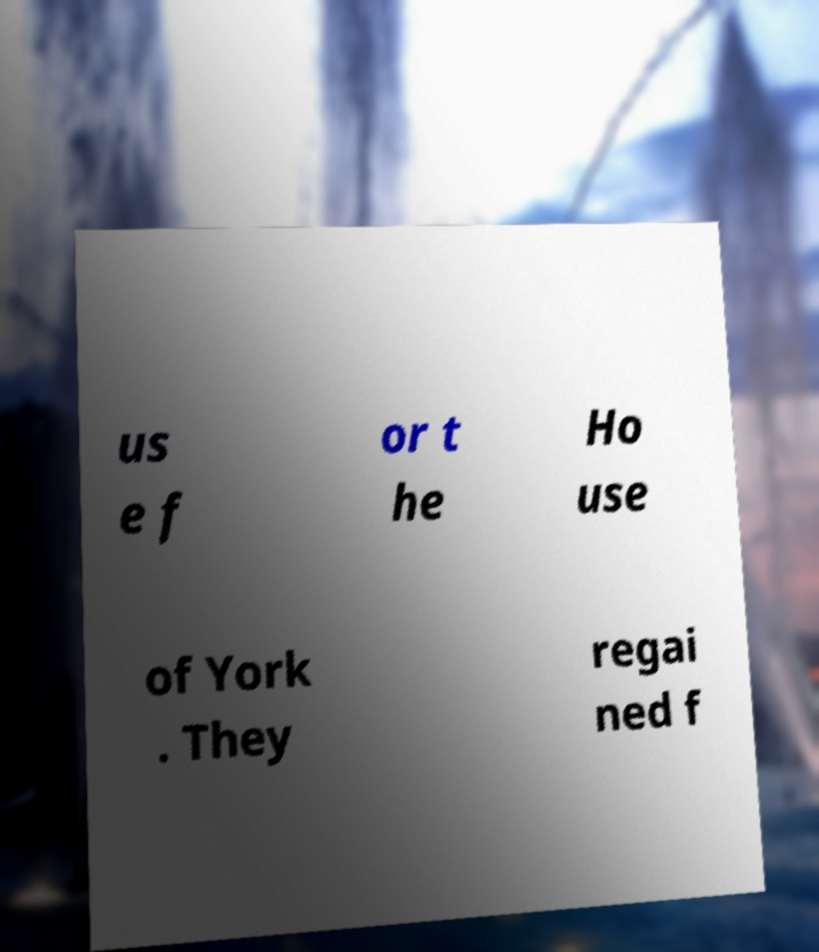Could you assist in decoding the text presented in this image and type it out clearly? us e f or t he Ho use of York . They regai ned f 